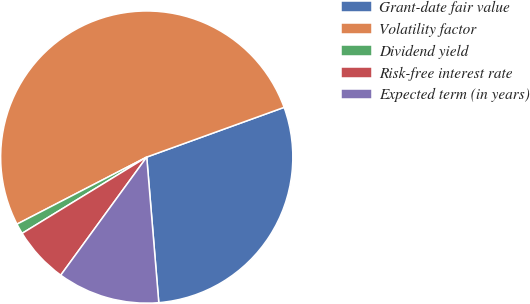<chart> <loc_0><loc_0><loc_500><loc_500><pie_chart><fcel>Grant-date fair value<fcel>Volatility factor<fcel>Dividend yield<fcel>Risk-free interest rate<fcel>Expected term (in years)<nl><fcel>29.21%<fcel>52.07%<fcel>1.15%<fcel>6.24%<fcel>11.33%<nl></chart> 